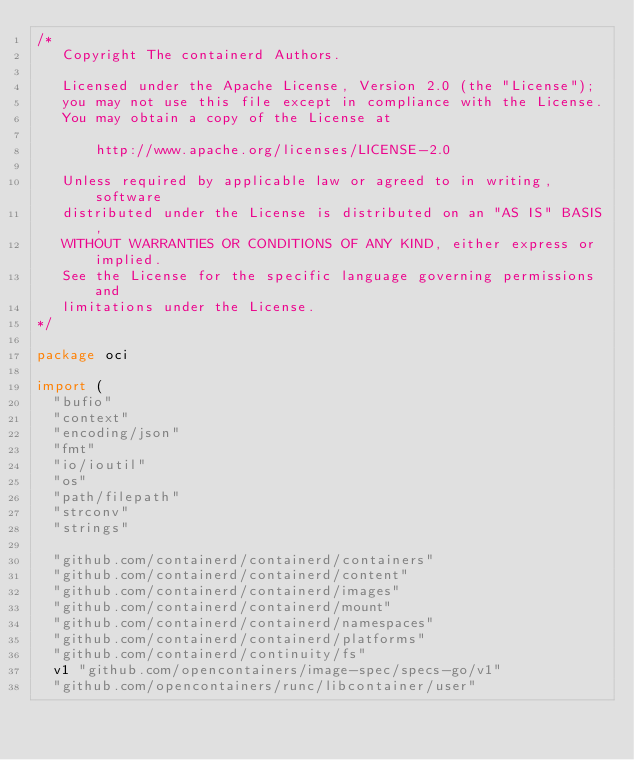<code> <loc_0><loc_0><loc_500><loc_500><_Go_>/*
   Copyright The containerd Authors.

   Licensed under the Apache License, Version 2.0 (the "License");
   you may not use this file except in compliance with the License.
   You may obtain a copy of the License at

       http://www.apache.org/licenses/LICENSE-2.0

   Unless required by applicable law or agreed to in writing, software
   distributed under the License is distributed on an "AS IS" BASIS,
   WITHOUT WARRANTIES OR CONDITIONS OF ANY KIND, either express or implied.
   See the License for the specific language governing permissions and
   limitations under the License.
*/

package oci

import (
	"bufio"
	"context"
	"encoding/json"
	"fmt"
	"io/ioutil"
	"os"
	"path/filepath"
	"strconv"
	"strings"

	"github.com/containerd/containerd/containers"
	"github.com/containerd/containerd/content"
	"github.com/containerd/containerd/images"
	"github.com/containerd/containerd/mount"
	"github.com/containerd/containerd/namespaces"
	"github.com/containerd/containerd/platforms"
	"github.com/containerd/continuity/fs"
	v1 "github.com/opencontainers/image-spec/specs-go/v1"
	"github.com/opencontainers/runc/libcontainer/user"</code> 